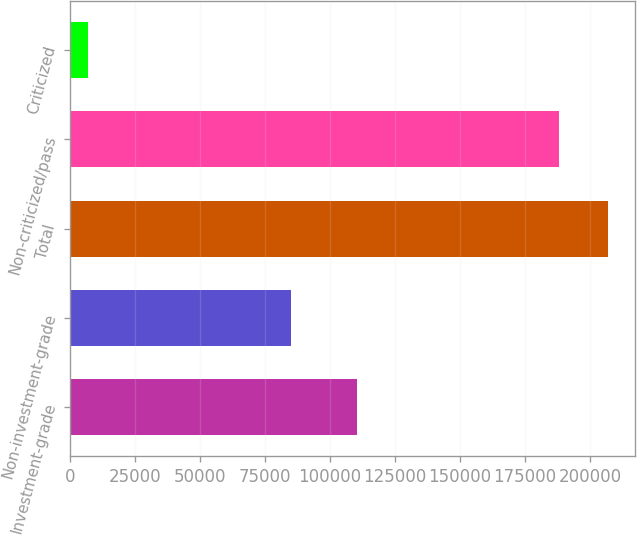<chart> <loc_0><loc_0><loc_500><loc_500><bar_chart><fcel>Investment-grade<fcel>Non-investment-grade<fcel>Total<fcel>Non-criticized/pass<fcel>Criticized<nl><fcel>110249<fcel>84826<fcel>206884<fcel>188076<fcel>6999<nl></chart> 